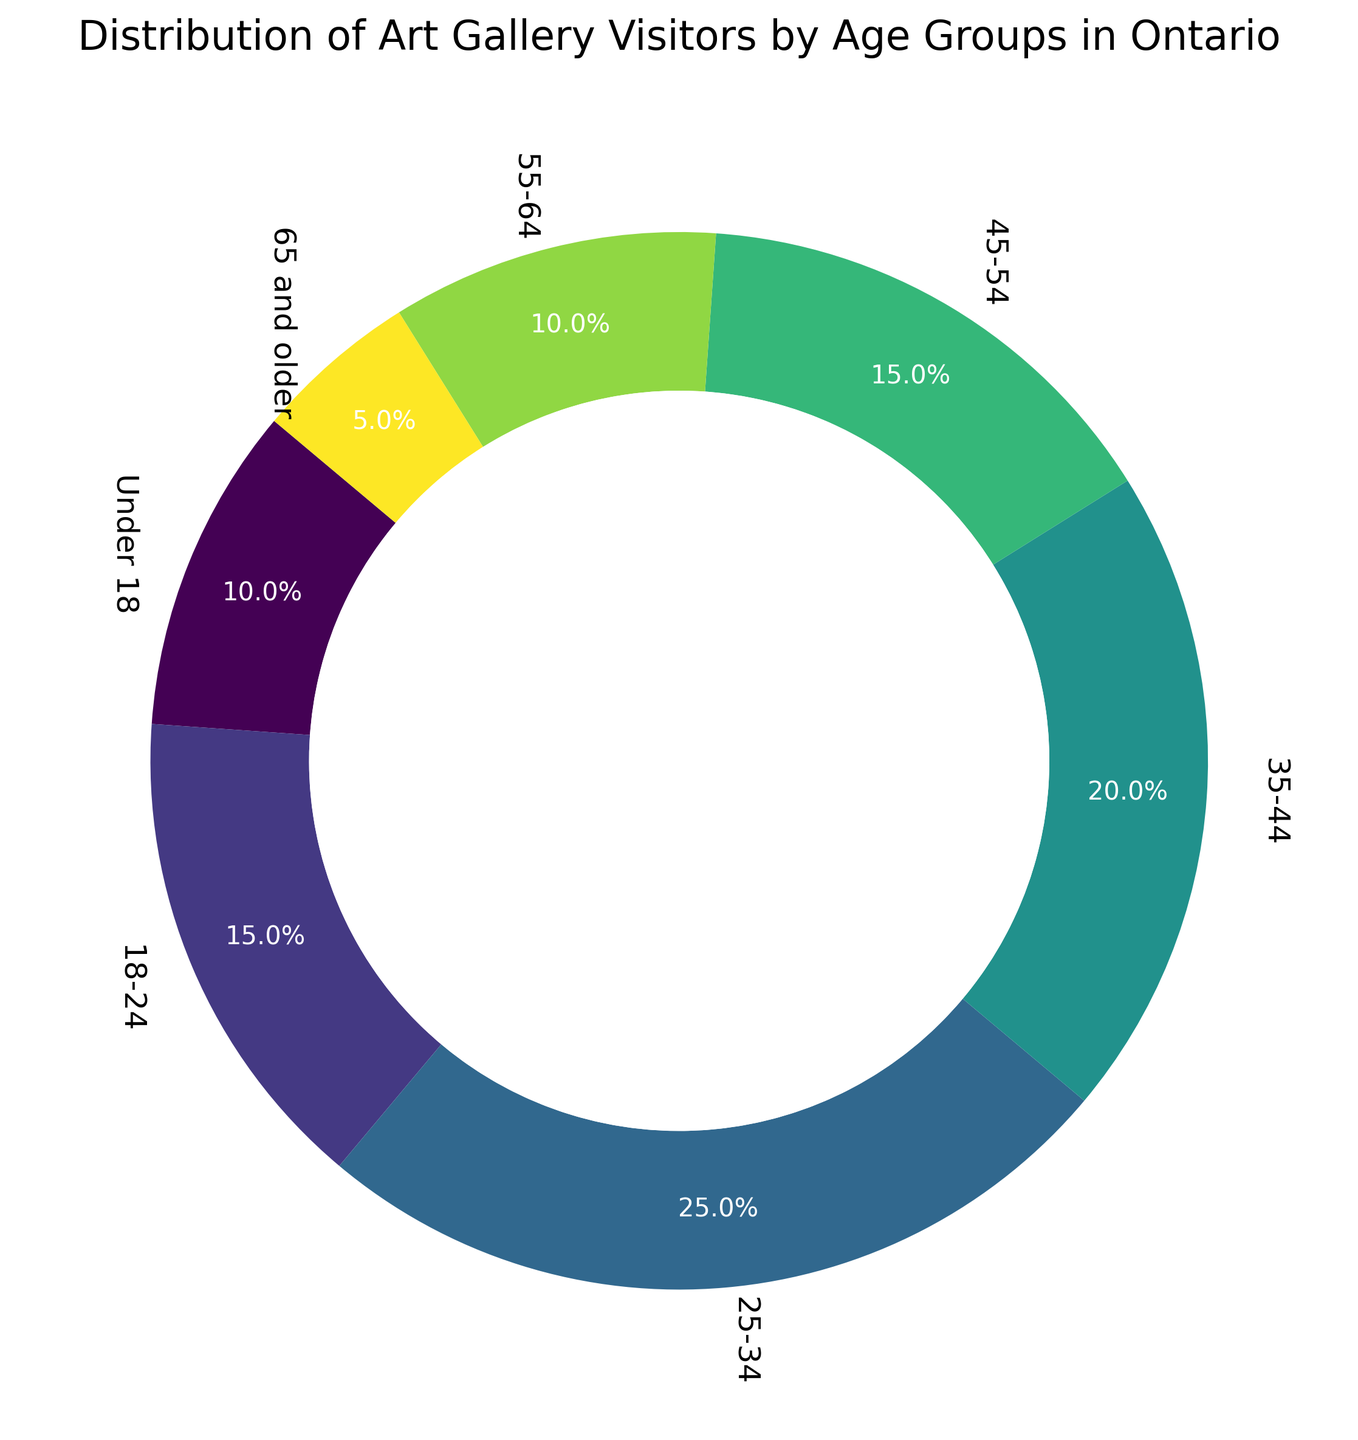What's the age group with the highest percentage of art gallery visitors in Ontario? Looking at the ring chart, the section labeled "25-34" is the largest, indicating it has the highest percentage of visitors.
Answer: 25-34 Which age group has the smallest percentage of art gallery visitors? In the ring chart, the smallest section is labeled "65 and older," which indicates it has the smallest percentage.
Answer: 65 and older What's the combined percentage of visitors under 18 and those between 18-24? According to the chart, visitors under 18 make up 10%, and those between 18-24 make up 15%. Adding these percentages together: 10% + 15% = 25%
Answer: 25% Is the percentage of visitors aged 25-34 greater than the percentage of those aged 45-54? The chart shows 25-34 has 25% and 45-54 has 15%. Since 25% is greater than 15%, the answer is yes.
Answer: Yes Which two age groups have the same percentage of art gallery visitors? Both the "18-24" and "45-54" sections are labeled with 15%, indicating that these two age groups have the same percentage of visitors.
Answer: 18-24 and 45-54 What's the difference in percentage between the 35-44 and 55-64 age groups? The chart shows the 35-44 age group at 20% and the 55-64 age group at 10%. The difference is 20% - 10% = 10%.
Answer: 10% If you summed the visitors percentages for age groups 25-34 and 35-44, would it be more than half of total visitors? Adding the percentages from the chart, 25-34 has 25% and 35-44 has 20%. The sum is 25% + 20% = 45%. Since this is less than 50%, it is not more than half the total.
Answer: No What percentage of the visitors are aged 18-54? Add the percentages for each age group within this range: 18-24 (15%), 25-34 (25%), 35-44 (20%), and 45-54 (15%). 15% + 25% + 20% + 15% = 75%.
Answer: 75% Is the percentage of visitors aged 55-64 twice the percentage of visitors aged 65 and older? The chart shows the percentage for 55-64 is 10%, and for 65 and older is 5%. Since 10% is indeed twice 5%, the answer is yes.
Answer: Yes What is the color of the section representing the age group of 18-24? Based on the color gradient in the ring chart, the section for 18-24 is a yellowish-green color.
Answer: Yellowish-green 